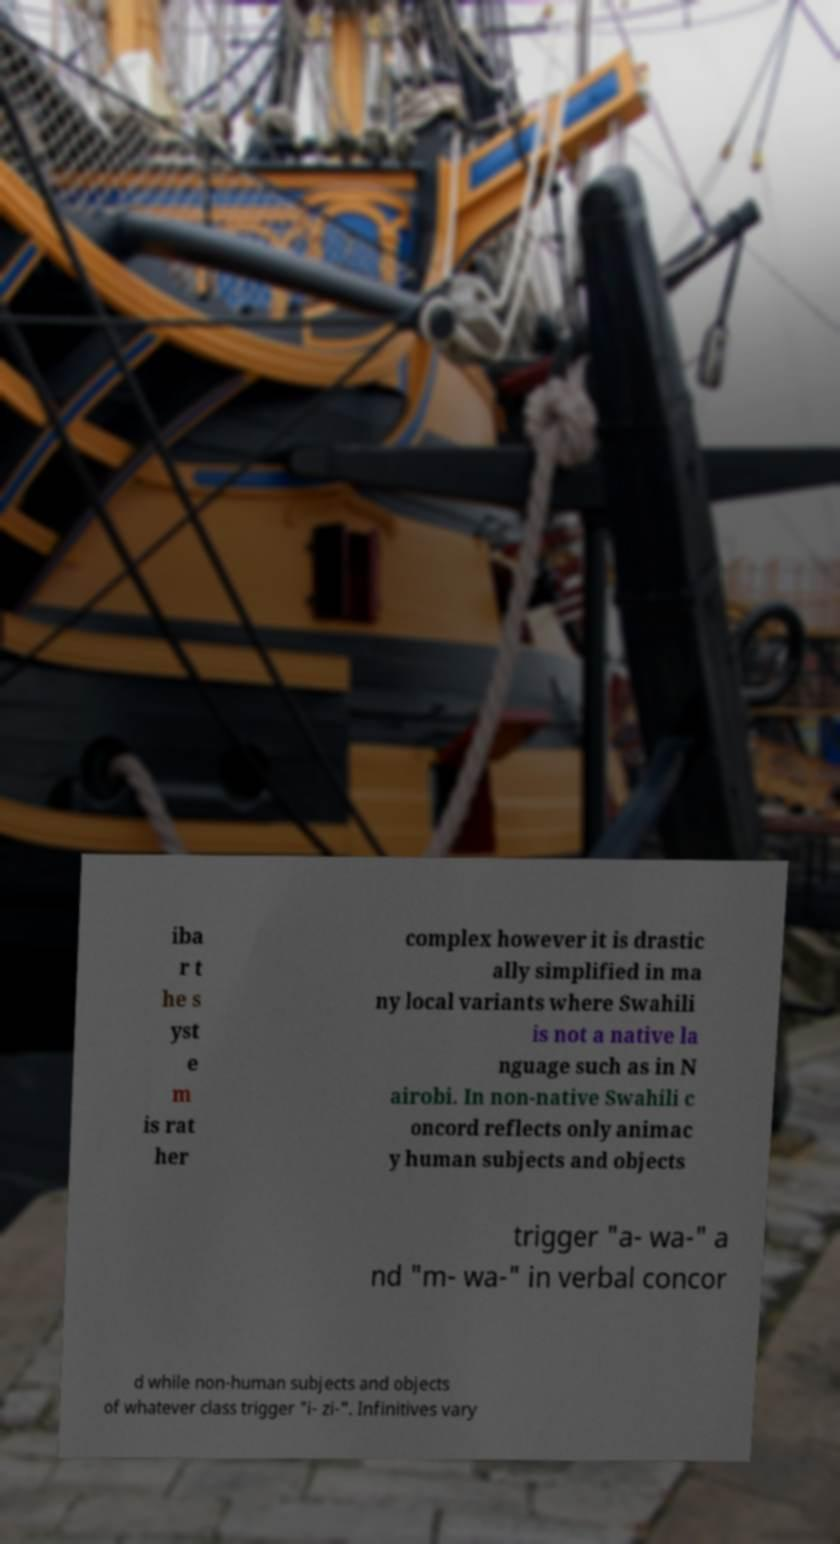What messages or text are displayed in this image? I need them in a readable, typed format. iba r t he s yst e m is rat her complex however it is drastic ally simplified in ma ny local variants where Swahili is not a native la nguage such as in N airobi. In non-native Swahili c oncord reflects only animac y human subjects and objects trigger "a- wa-" a nd "m- wa-" in verbal concor d while non-human subjects and objects of whatever class trigger "i- zi-". Infinitives vary 